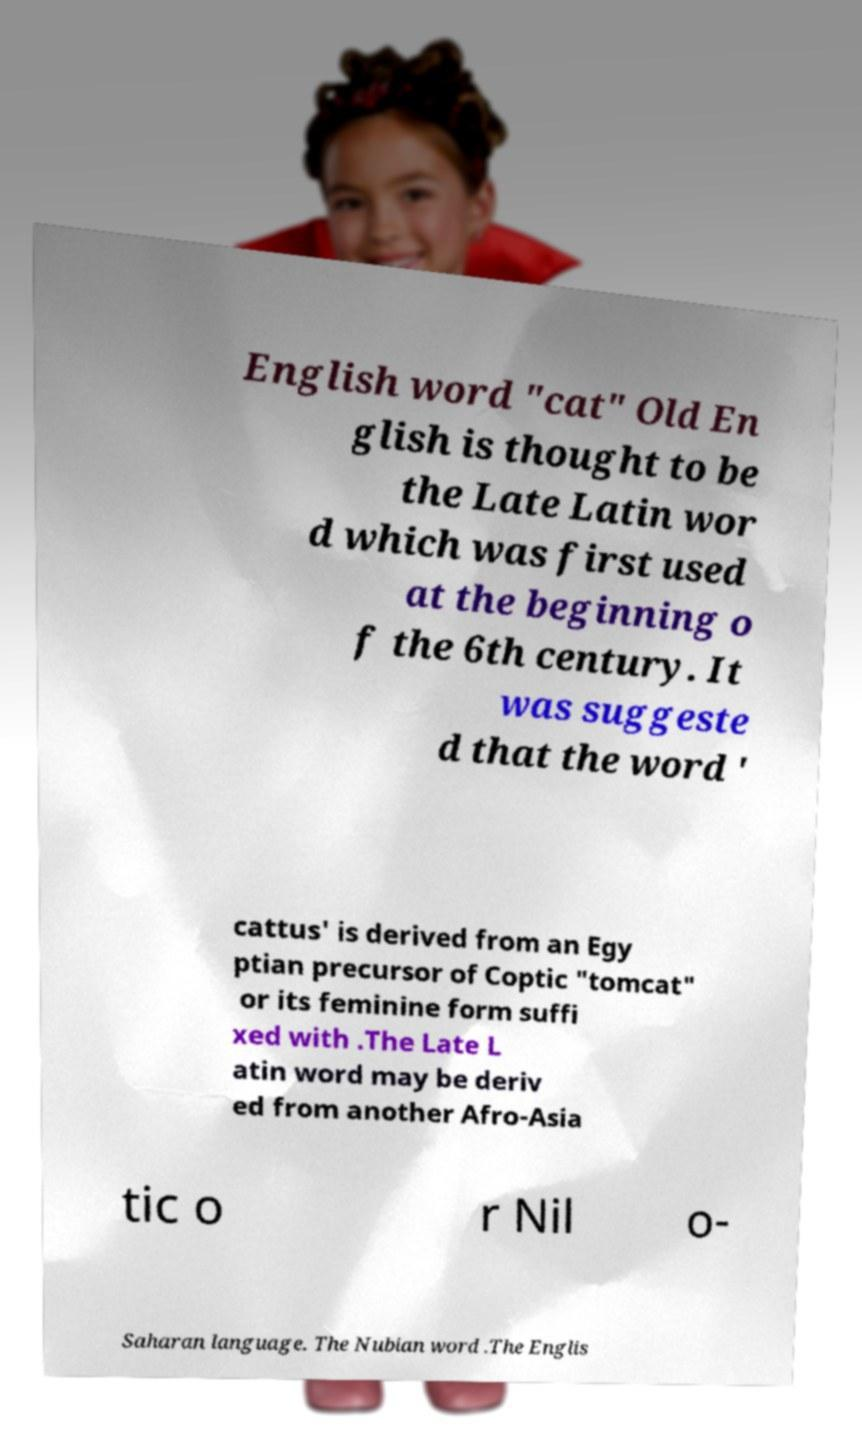Could you assist in decoding the text presented in this image and type it out clearly? English word "cat" Old En glish is thought to be the Late Latin wor d which was first used at the beginning o f the 6th century. It was suggeste d that the word ' cattus' is derived from an Egy ptian precursor of Coptic "tomcat" or its feminine form suffi xed with .The Late L atin word may be deriv ed from another Afro-Asia tic o r Nil o- Saharan language. The Nubian word .The Englis 